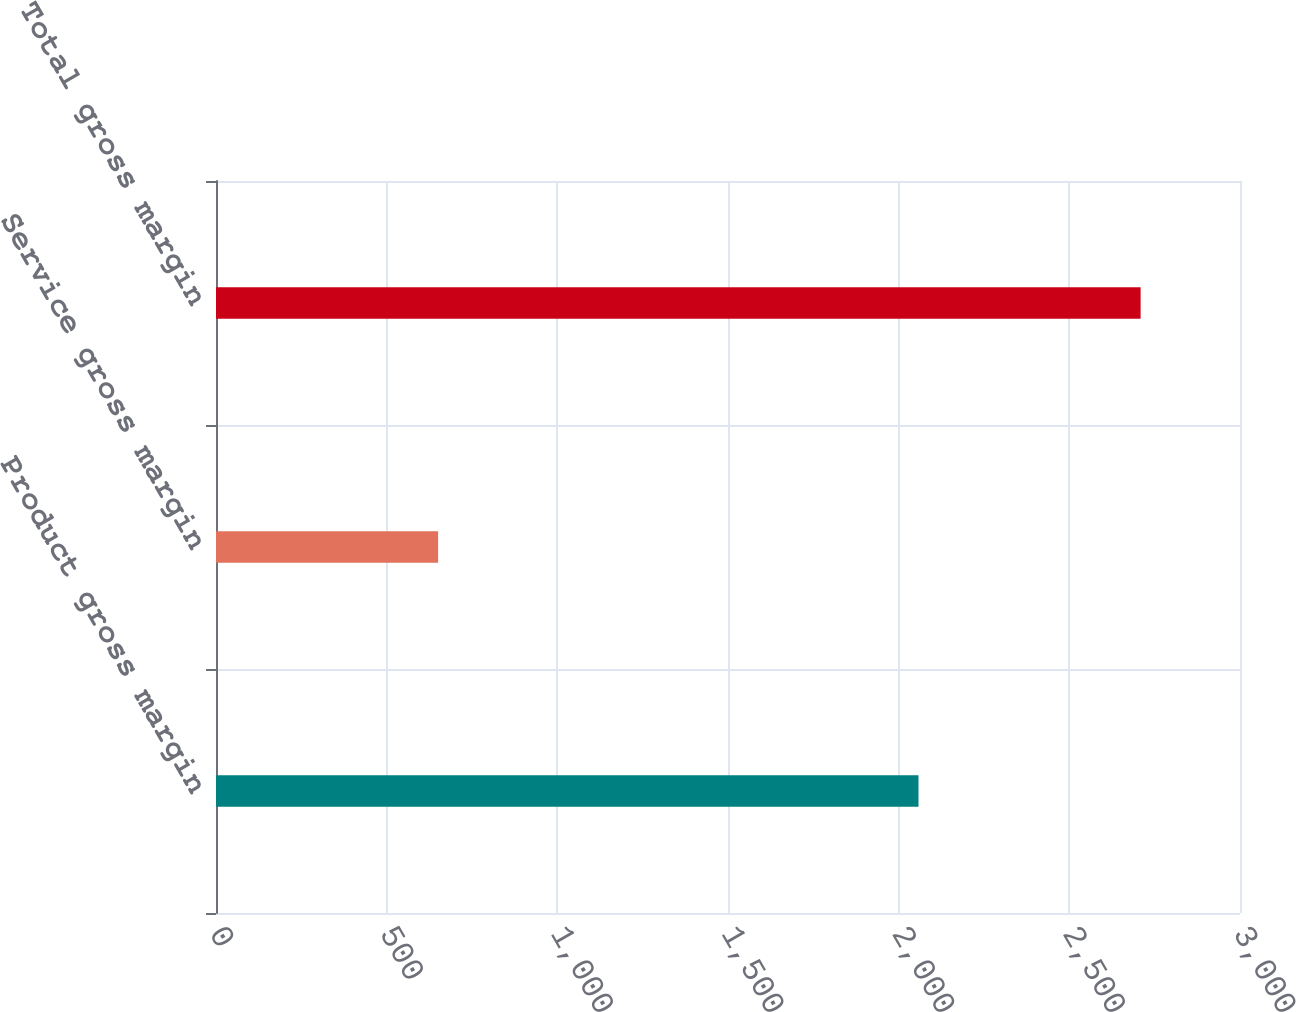Convert chart. <chart><loc_0><loc_0><loc_500><loc_500><bar_chart><fcel>Product gross margin<fcel>Service gross margin<fcel>Total gross margin<nl><fcel>2058.1<fcel>650.7<fcel>2708.8<nl></chart> 